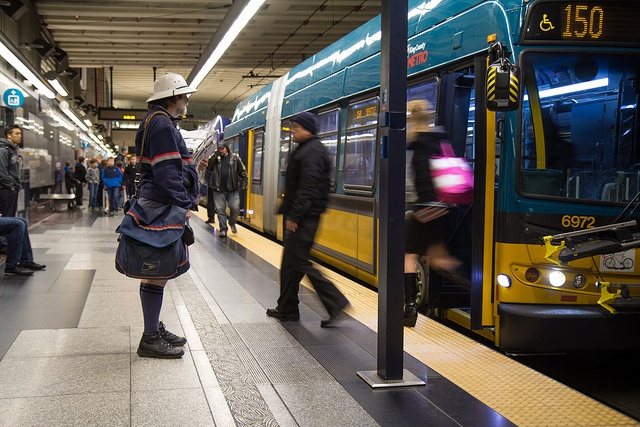Describe the objects in this image and their specific colors. I can see train in black, gray, and olive tones, people in black, gray, and maroon tones, people in black, maroon, gray, and lavender tones, people in black, maroon, and gray tones, and handbag in black, gray, and darkblue tones in this image. 